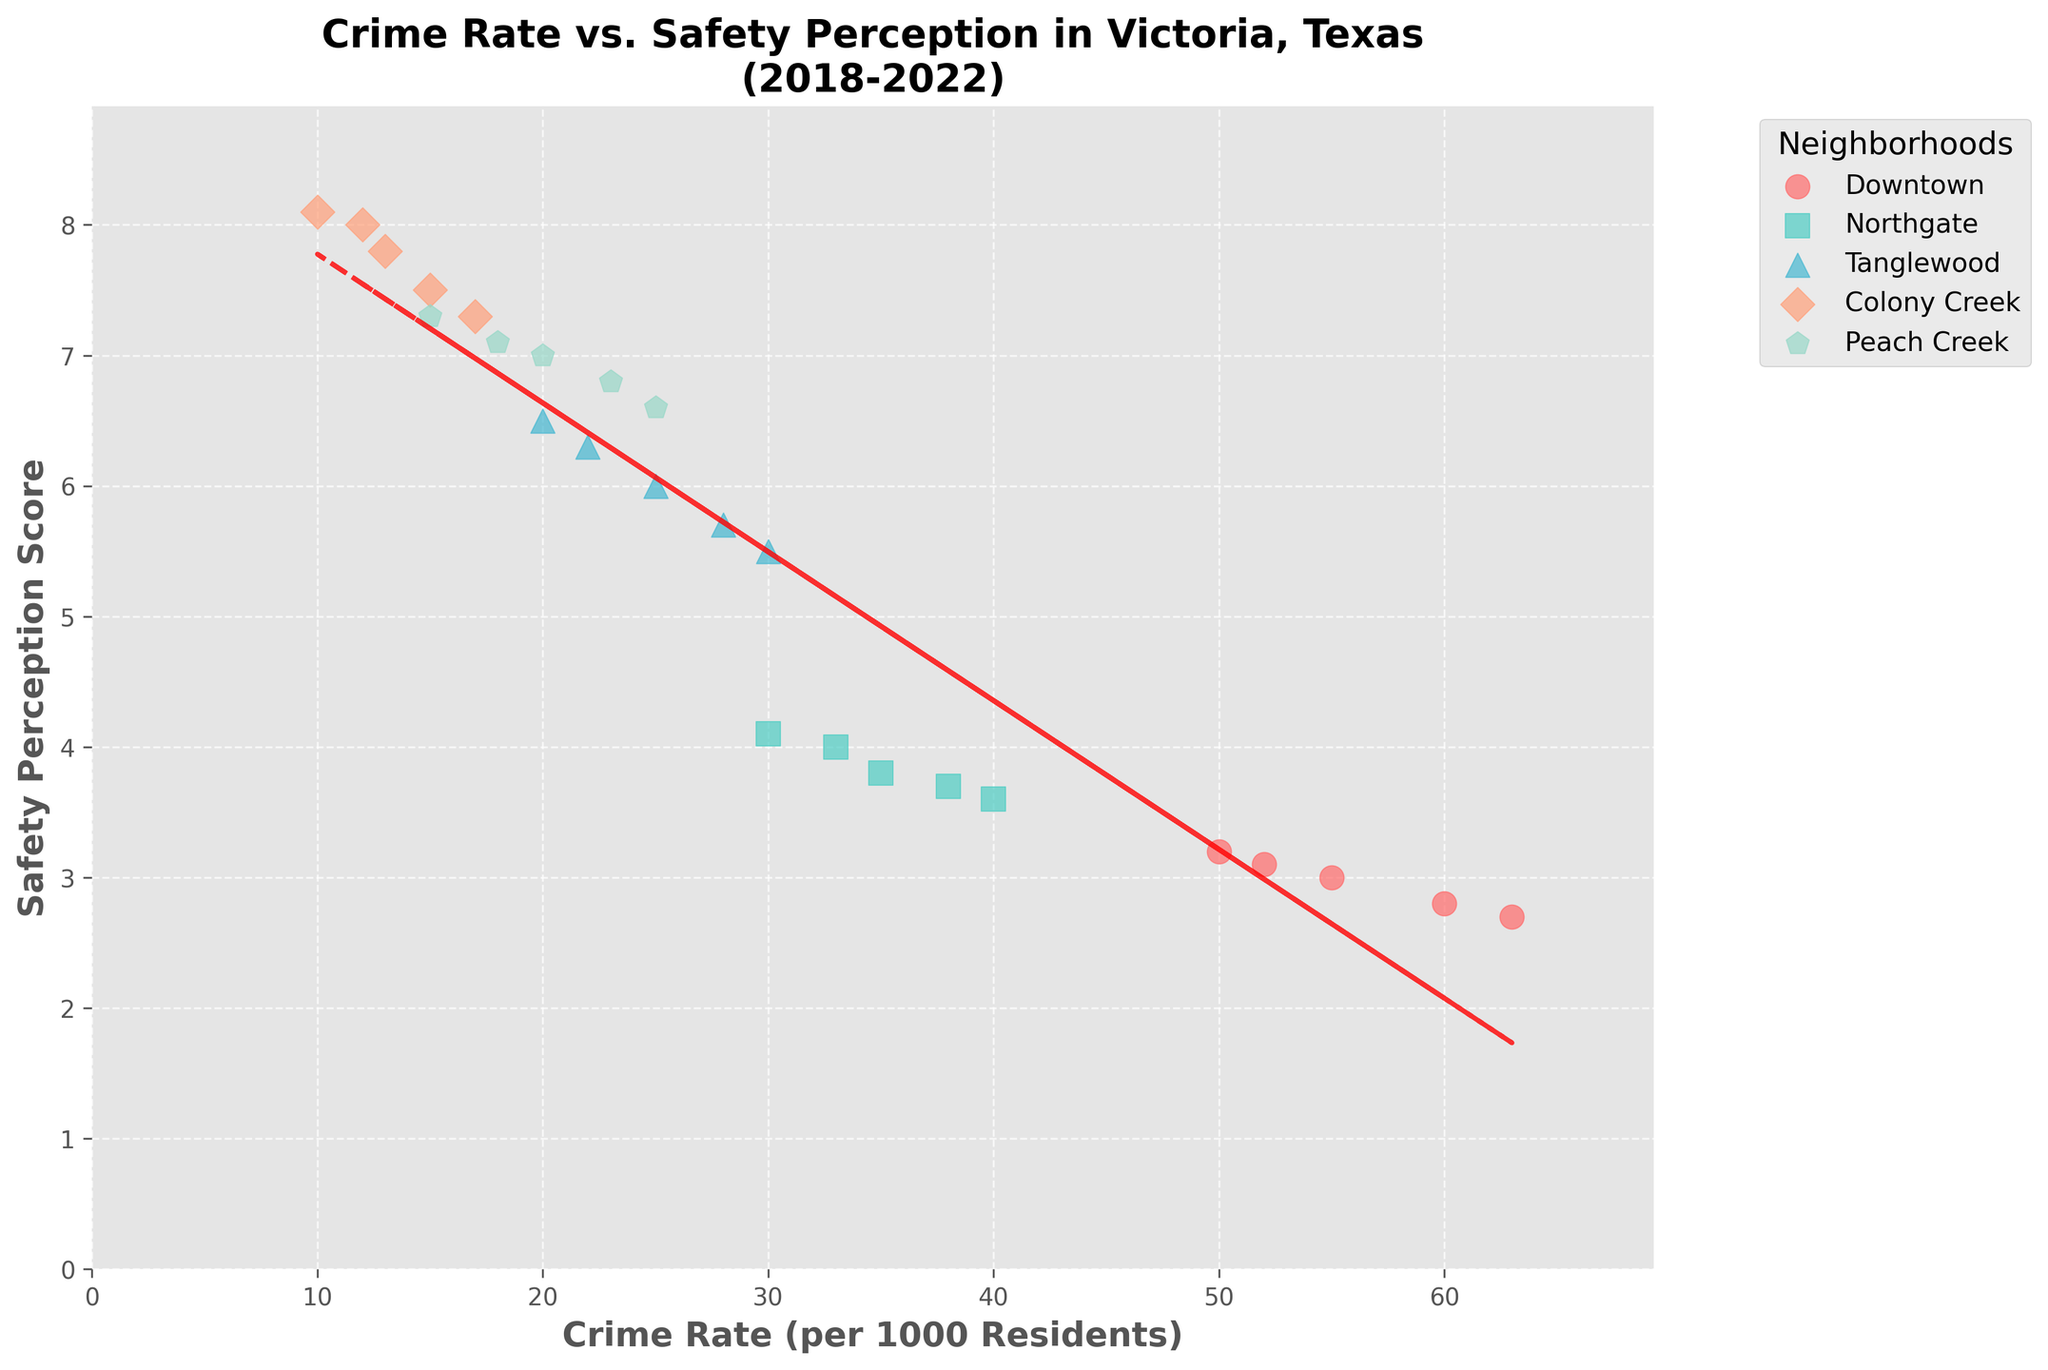What's the crime rate range represented on the x-axis? The x-axis is labeled "Crime Rate (per 1000 Residents)", and the data points start from around 10 and go up to the highest point, which is approximately 63.
Answer: 10 to 63 How does the safety perception score change as the crime rate increases according to the trend line? The trend line is red and dashed, showing that as the crime rate increases, the safety perception score decreases.
Answer: Decreases Which neighborhood has the highest crime rate in 2022? For 2022, the data indicates the crime rate for each neighborhood. The highest value is around 63, which corresponds to Downtown.
Answer: Downtown What is the general relationship between crime rates and safety perception scores across all neighborhoods? The trend line shows an inverse relationship; as crime rates increase, safety perception scores decrease.
Answer: Inverse relationship Are there any neighborhoods that defy the general trend shown by the trend line? By looking at the scatter points, Peach Creek, which has a low crime rate and a high safety perception score, slightly deviates from the general inverse trend.
Answer: Peach Creek Which year exhibits the lowest safety perception score for Downtown? Look at the trend over the years for Downtown. The lowest safety perception score is in the year when the crime rate is the highest, which is 2022 with a score of 2.7.
Answer: 2022 Which neighborhood shows the most considerable increase in crime rate from 2018 to 2022? Calculate the difference in crime rates for each neighborhood from 2018 to 2022. Downtown shows the largest increase from 50 to 63.
Answer: Downtown What is the average safety perception score for Tanglewood from 2018 to 2022? Sum the safety perception scores for Tanglewood across the years (6.5 + 6.3 + 6.0 + 5.7 + 5.5) which equals 30, and then divide by the number of years (5).
Answer: 6.0 Comparing Colony Creek and Peach Creek, which has a higher safety perception score in 2021? Check the 2021 safety perception scores for both neighborhoods. Colony Creek has a score of 7.5, and Peach Creek has 6.8.
Answer: Colony Creek Is the relationship between crime rates and safety perception stronger or weaker for Northgate compared to the overall trend? Compare the individual points for Northgate to the overall trend line. Northgate follows the overall inverse trend but appears to have a weaker relationship because its points are closer together.
Answer: Weaker 